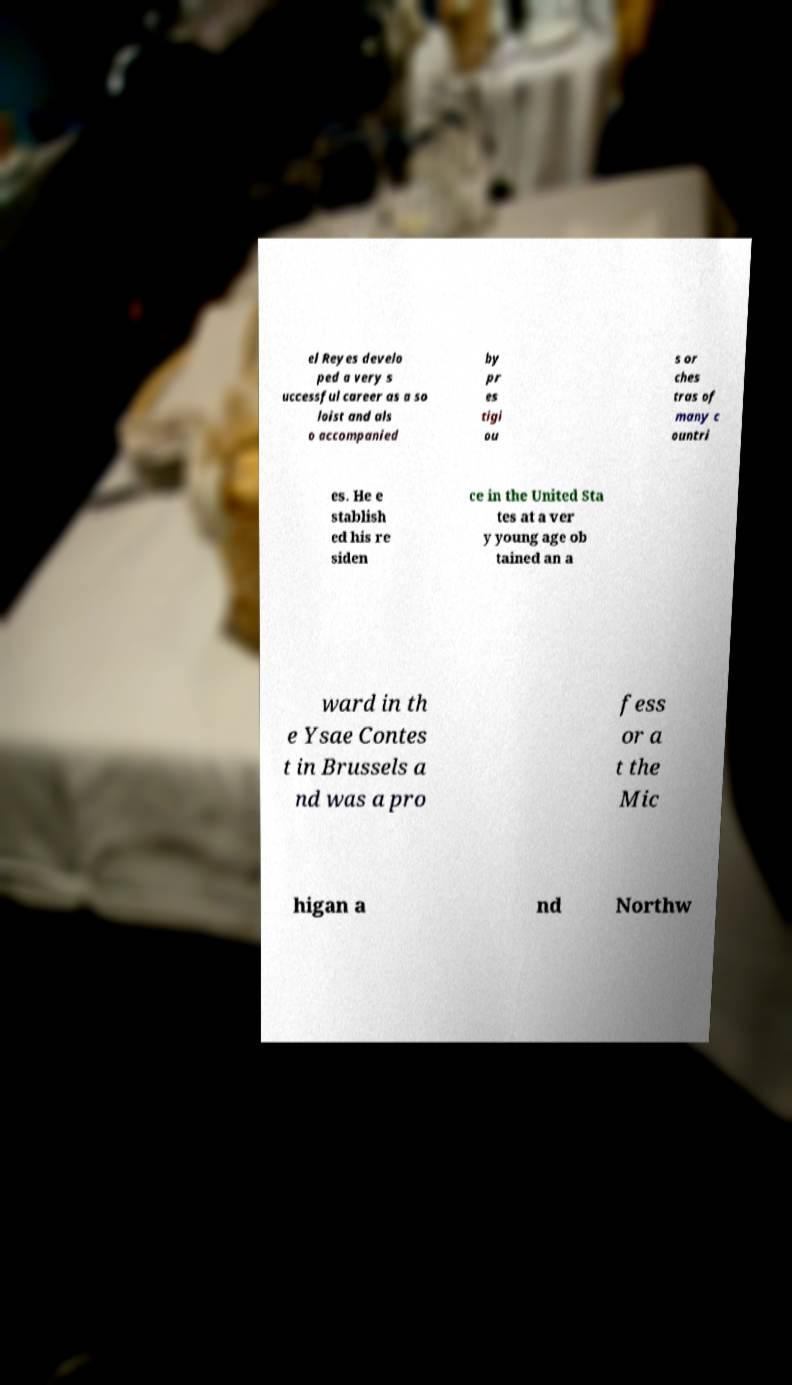Can you accurately transcribe the text from the provided image for me? el Reyes develo ped a very s uccessful career as a so loist and als o accompanied by pr es tigi ou s or ches tras of many c ountri es. He e stablish ed his re siden ce in the United Sta tes at a ver y young age ob tained an a ward in th e Ysae Contes t in Brussels a nd was a pro fess or a t the Mic higan a nd Northw 